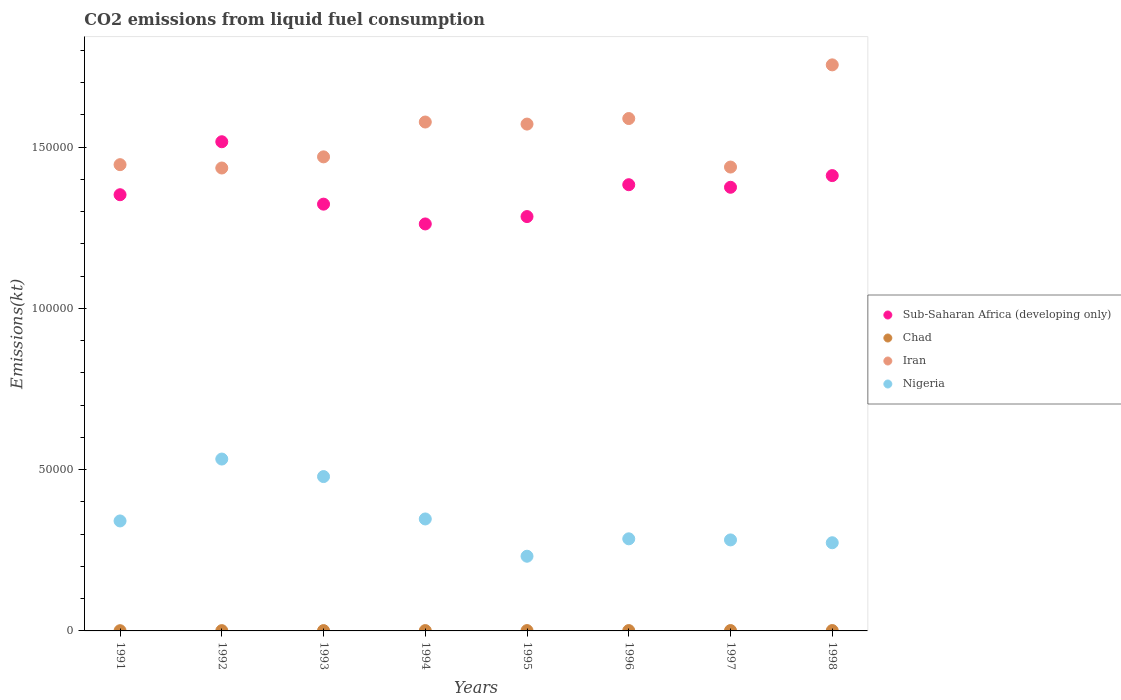Is the number of dotlines equal to the number of legend labels?
Ensure brevity in your answer.  Yes. What is the amount of CO2 emitted in Nigeria in 1992?
Ensure brevity in your answer.  5.33e+04. Across all years, what is the maximum amount of CO2 emitted in Iran?
Provide a succinct answer. 1.75e+05. Across all years, what is the minimum amount of CO2 emitted in Sub-Saharan Africa (developing only)?
Your answer should be very brief. 1.26e+05. What is the total amount of CO2 emitted in Sub-Saharan Africa (developing only) in the graph?
Give a very brief answer. 1.09e+06. What is the difference between the amount of CO2 emitted in Sub-Saharan Africa (developing only) in 1992 and that in 1994?
Provide a short and direct response. 2.55e+04. What is the difference between the amount of CO2 emitted in Chad in 1992 and the amount of CO2 emitted in Nigeria in 1995?
Keep it short and to the point. -2.31e+04. What is the average amount of CO2 emitted in Chad per year?
Provide a short and direct response. 99.47. In the year 1997, what is the difference between the amount of CO2 emitted in Nigeria and amount of CO2 emitted in Sub-Saharan Africa (developing only)?
Your answer should be very brief. -1.09e+05. What is the ratio of the amount of CO2 emitted in Sub-Saharan Africa (developing only) in 1994 to that in 1998?
Keep it short and to the point. 0.89. What is the difference between the highest and the second highest amount of CO2 emitted in Iran?
Provide a succinct answer. 1.66e+04. What is the difference between the highest and the lowest amount of CO2 emitted in Sub-Saharan Africa (developing only)?
Offer a terse response. 2.55e+04. In how many years, is the amount of CO2 emitted in Chad greater than the average amount of CO2 emitted in Chad taken over all years?
Give a very brief answer. 5. Is the sum of the amount of CO2 emitted in Chad in 1994 and 1997 greater than the maximum amount of CO2 emitted in Iran across all years?
Offer a terse response. No. Is it the case that in every year, the sum of the amount of CO2 emitted in Sub-Saharan Africa (developing only) and amount of CO2 emitted in Iran  is greater than the sum of amount of CO2 emitted in Chad and amount of CO2 emitted in Nigeria?
Your answer should be very brief. Yes. Does the amount of CO2 emitted in Iran monotonically increase over the years?
Give a very brief answer. No. Is the amount of CO2 emitted in Iran strictly greater than the amount of CO2 emitted in Nigeria over the years?
Your answer should be compact. Yes. How many dotlines are there?
Give a very brief answer. 4. How many years are there in the graph?
Give a very brief answer. 8. What is the difference between two consecutive major ticks on the Y-axis?
Your answer should be compact. 5.00e+04. Does the graph contain any zero values?
Keep it short and to the point. No. Does the graph contain grids?
Keep it short and to the point. No. Where does the legend appear in the graph?
Make the answer very short. Center right. What is the title of the graph?
Your answer should be compact. CO2 emissions from liquid fuel consumption. Does "European Union" appear as one of the legend labels in the graph?
Your answer should be very brief. No. What is the label or title of the X-axis?
Offer a terse response. Years. What is the label or title of the Y-axis?
Keep it short and to the point. Emissions(kt). What is the Emissions(kt) of Sub-Saharan Africa (developing only) in 1991?
Your response must be concise. 1.35e+05. What is the Emissions(kt) in Chad in 1991?
Keep it short and to the point. 69.67. What is the Emissions(kt) in Iran in 1991?
Provide a short and direct response. 1.45e+05. What is the Emissions(kt) of Nigeria in 1991?
Provide a succinct answer. 3.41e+04. What is the Emissions(kt) of Sub-Saharan Africa (developing only) in 1992?
Ensure brevity in your answer.  1.52e+05. What is the Emissions(kt) in Chad in 1992?
Make the answer very short. 88.01. What is the Emissions(kt) in Iran in 1992?
Provide a short and direct response. 1.44e+05. What is the Emissions(kt) of Nigeria in 1992?
Give a very brief answer. 5.33e+04. What is the Emissions(kt) of Sub-Saharan Africa (developing only) in 1993?
Your answer should be compact. 1.32e+05. What is the Emissions(kt) in Chad in 1993?
Offer a terse response. 99.01. What is the Emissions(kt) in Iran in 1993?
Offer a very short reply. 1.47e+05. What is the Emissions(kt) of Nigeria in 1993?
Provide a succinct answer. 4.79e+04. What is the Emissions(kt) of Sub-Saharan Africa (developing only) in 1994?
Provide a short and direct response. 1.26e+05. What is the Emissions(kt) in Chad in 1994?
Provide a short and direct response. 102.68. What is the Emissions(kt) in Iran in 1994?
Provide a short and direct response. 1.58e+05. What is the Emissions(kt) of Nigeria in 1994?
Offer a very short reply. 3.47e+04. What is the Emissions(kt) of Sub-Saharan Africa (developing only) in 1995?
Give a very brief answer. 1.28e+05. What is the Emissions(kt) in Chad in 1995?
Offer a terse response. 102.68. What is the Emissions(kt) in Iran in 1995?
Provide a succinct answer. 1.57e+05. What is the Emissions(kt) in Nigeria in 1995?
Ensure brevity in your answer.  2.32e+04. What is the Emissions(kt) in Sub-Saharan Africa (developing only) in 1996?
Give a very brief answer. 1.38e+05. What is the Emissions(kt) of Chad in 1996?
Offer a very short reply. 106.34. What is the Emissions(kt) in Iran in 1996?
Ensure brevity in your answer.  1.59e+05. What is the Emissions(kt) of Nigeria in 1996?
Give a very brief answer. 2.86e+04. What is the Emissions(kt) of Sub-Saharan Africa (developing only) in 1997?
Offer a terse response. 1.38e+05. What is the Emissions(kt) of Chad in 1997?
Offer a very short reply. 113.68. What is the Emissions(kt) in Iran in 1997?
Make the answer very short. 1.44e+05. What is the Emissions(kt) of Nigeria in 1997?
Your answer should be very brief. 2.82e+04. What is the Emissions(kt) in Sub-Saharan Africa (developing only) in 1998?
Offer a very short reply. 1.41e+05. What is the Emissions(kt) in Chad in 1998?
Your answer should be compact. 113.68. What is the Emissions(kt) in Iran in 1998?
Give a very brief answer. 1.75e+05. What is the Emissions(kt) in Nigeria in 1998?
Make the answer very short. 2.73e+04. Across all years, what is the maximum Emissions(kt) of Sub-Saharan Africa (developing only)?
Your answer should be compact. 1.52e+05. Across all years, what is the maximum Emissions(kt) of Chad?
Provide a succinct answer. 113.68. Across all years, what is the maximum Emissions(kt) of Iran?
Your answer should be very brief. 1.75e+05. Across all years, what is the maximum Emissions(kt) in Nigeria?
Keep it short and to the point. 5.33e+04. Across all years, what is the minimum Emissions(kt) in Sub-Saharan Africa (developing only)?
Offer a very short reply. 1.26e+05. Across all years, what is the minimum Emissions(kt) in Chad?
Ensure brevity in your answer.  69.67. Across all years, what is the minimum Emissions(kt) in Iran?
Your response must be concise. 1.44e+05. Across all years, what is the minimum Emissions(kt) of Nigeria?
Offer a terse response. 2.32e+04. What is the total Emissions(kt) in Sub-Saharan Africa (developing only) in the graph?
Your answer should be compact. 1.09e+06. What is the total Emissions(kt) in Chad in the graph?
Provide a short and direct response. 795.74. What is the total Emissions(kt) in Iran in the graph?
Offer a very short reply. 1.23e+06. What is the total Emissions(kt) in Nigeria in the graph?
Offer a terse response. 2.77e+05. What is the difference between the Emissions(kt) of Sub-Saharan Africa (developing only) in 1991 and that in 1992?
Give a very brief answer. -1.64e+04. What is the difference between the Emissions(kt) in Chad in 1991 and that in 1992?
Make the answer very short. -18.34. What is the difference between the Emissions(kt) in Iran in 1991 and that in 1992?
Your answer should be compact. 1037.76. What is the difference between the Emissions(kt) of Nigeria in 1991 and that in 1992?
Provide a short and direct response. -1.92e+04. What is the difference between the Emissions(kt) in Sub-Saharan Africa (developing only) in 1991 and that in 1993?
Keep it short and to the point. 2920.51. What is the difference between the Emissions(kt) in Chad in 1991 and that in 1993?
Provide a succinct answer. -29.34. What is the difference between the Emissions(kt) in Iran in 1991 and that in 1993?
Provide a succinct answer. -2416.55. What is the difference between the Emissions(kt) in Nigeria in 1991 and that in 1993?
Give a very brief answer. -1.38e+04. What is the difference between the Emissions(kt) in Sub-Saharan Africa (developing only) in 1991 and that in 1994?
Offer a terse response. 9058.79. What is the difference between the Emissions(kt) of Chad in 1991 and that in 1994?
Your answer should be compact. -33. What is the difference between the Emissions(kt) in Iran in 1991 and that in 1994?
Your answer should be very brief. -1.32e+04. What is the difference between the Emissions(kt) in Nigeria in 1991 and that in 1994?
Offer a very short reply. -616.06. What is the difference between the Emissions(kt) in Sub-Saharan Africa (developing only) in 1991 and that in 1995?
Ensure brevity in your answer.  6773.64. What is the difference between the Emissions(kt) in Chad in 1991 and that in 1995?
Offer a terse response. -33. What is the difference between the Emissions(kt) in Iran in 1991 and that in 1995?
Ensure brevity in your answer.  -1.26e+04. What is the difference between the Emissions(kt) of Nigeria in 1991 and that in 1995?
Offer a terse response. 1.09e+04. What is the difference between the Emissions(kt) in Sub-Saharan Africa (developing only) in 1991 and that in 1996?
Make the answer very short. -3105.17. What is the difference between the Emissions(kt) of Chad in 1991 and that in 1996?
Provide a succinct answer. -36.67. What is the difference between the Emissions(kt) of Iran in 1991 and that in 1996?
Keep it short and to the point. -1.43e+04. What is the difference between the Emissions(kt) in Nigeria in 1991 and that in 1996?
Your response must be concise. 5540.84. What is the difference between the Emissions(kt) in Sub-Saharan Africa (developing only) in 1991 and that in 1997?
Your response must be concise. -2311.31. What is the difference between the Emissions(kt) in Chad in 1991 and that in 1997?
Ensure brevity in your answer.  -44. What is the difference between the Emissions(kt) in Iran in 1991 and that in 1997?
Give a very brief answer. 744.4. What is the difference between the Emissions(kt) in Nigeria in 1991 and that in 1997?
Keep it short and to the point. 5881.87. What is the difference between the Emissions(kt) in Sub-Saharan Africa (developing only) in 1991 and that in 1998?
Keep it short and to the point. -5929.79. What is the difference between the Emissions(kt) of Chad in 1991 and that in 1998?
Your response must be concise. -44. What is the difference between the Emissions(kt) of Iran in 1991 and that in 1998?
Your response must be concise. -3.09e+04. What is the difference between the Emissions(kt) in Nigeria in 1991 and that in 1998?
Give a very brief answer. 6758.28. What is the difference between the Emissions(kt) in Sub-Saharan Africa (developing only) in 1992 and that in 1993?
Ensure brevity in your answer.  1.93e+04. What is the difference between the Emissions(kt) in Chad in 1992 and that in 1993?
Your answer should be compact. -11. What is the difference between the Emissions(kt) of Iran in 1992 and that in 1993?
Keep it short and to the point. -3454.31. What is the difference between the Emissions(kt) of Nigeria in 1992 and that in 1993?
Provide a succinct answer. 5434.49. What is the difference between the Emissions(kt) of Sub-Saharan Africa (developing only) in 1992 and that in 1994?
Give a very brief answer. 2.55e+04. What is the difference between the Emissions(kt) in Chad in 1992 and that in 1994?
Keep it short and to the point. -14.67. What is the difference between the Emissions(kt) of Iran in 1992 and that in 1994?
Offer a terse response. -1.43e+04. What is the difference between the Emissions(kt) of Nigeria in 1992 and that in 1994?
Provide a short and direct response. 1.86e+04. What is the difference between the Emissions(kt) of Sub-Saharan Africa (developing only) in 1992 and that in 1995?
Your answer should be compact. 2.32e+04. What is the difference between the Emissions(kt) of Chad in 1992 and that in 1995?
Make the answer very short. -14.67. What is the difference between the Emissions(kt) of Iran in 1992 and that in 1995?
Keep it short and to the point. -1.36e+04. What is the difference between the Emissions(kt) in Nigeria in 1992 and that in 1995?
Keep it short and to the point. 3.01e+04. What is the difference between the Emissions(kt) in Sub-Saharan Africa (developing only) in 1992 and that in 1996?
Your response must be concise. 1.33e+04. What is the difference between the Emissions(kt) in Chad in 1992 and that in 1996?
Ensure brevity in your answer.  -18.34. What is the difference between the Emissions(kt) in Iran in 1992 and that in 1996?
Give a very brief answer. -1.53e+04. What is the difference between the Emissions(kt) of Nigeria in 1992 and that in 1996?
Keep it short and to the point. 2.47e+04. What is the difference between the Emissions(kt) in Sub-Saharan Africa (developing only) in 1992 and that in 1997?
Your response must be concise. 1.41e+04. What is the difference between the Emissions(kt) in Chad in 1992 and that in 1997?
Offer a terse response. -25.67. What is the difference between the Emissions(kt) of Iran in 1992 and that in 1997?
Your answer should be very brief. -293.36. What is the difference between the Emissions(kt) in Nigeria in 1992 and that in 1997?
Your response must be concise. 2.51e+04. What is the difference between the Emissions(kt) of Sub-Saharan Africa (developing only) in 1992 and that in 1998?
Offer a terse response. 1.05e+04. What is the difference between the Emissions(kt) of Chad in 1992 and that in 1998?
Make the answer very short. -25.67. What is the difference between the Emissions(kt) of Iran in 1992 and that in 1998?
Offer a terse response. -3.20e+04. What is the difference between the Emissions(kt) of Nigeria in 1992 and that in 1998?
Keep it short and to the point. 2.59e+04. What is the difference between the Emissions(kt) in Sub-Saharan Africa (developing only) in 1993 and that in 1994?
Provide a succinct answer. 6138.28. What is the difference between the Emissions(kt) in Chad in 1993 and that in 1994?
Keep it short and to the point. -3.67. What is the difference between the Emissions(kt) in Iran in 1993 and that in 1994?
Your answer should be very brief. -1.08e+04. What is the difference between the Emissions(kt) in Nigeria in 1993 and that in 1994?
Offer a terse response. 1.31e+04. What is the difference between the Emissions(kt) of Sub-Saharan Africa (developing only) in 1993 and that in 1995?
Your answer should be compact. 3853.13. What is the difference between the Emissions(kt) of Chad in 1993 and that in 1995?
Give a very brief answer. -3.67. What is the difference between the Emissions(kt) of Iran in 1993 and that in 1995?
Give a very brief answer. -1.02e+04. What is the difference between the Emissions(kt) of Nigeria in 1993 and that in 1995?
Your answer should be very brief. 2.47e+04. What is the difference between the Emissions(kt) in Sub-Saharan Africa (developing only) in 1993 and that in 1996?
Your answer should be compact. -6025.69. What is the difference between the Emissions(kt) of Chad in 1993 and that in 1996?
Ensure brevity in your answer.  -7.33. What is the difference between the Emissions(kt) of Iran in 1993 and that in 1996?
Offer a terse response. -1.19e+04. What is the difference between the Emissions(kt) in Nigeria in 1993 and that in 1996?
Your answer should be compact. 1.93e+04. What is the difference between the Emissions(kt) in Sub-Saharan Africa (developing only) in 1993 and that in 1997?
Provide a succinct answer. -5231.82. What is the difference between the Emissions(kt) in Chad in 1993 and that in 1997?
Your answer should be very brief. -14.67. What is the difference between the Emissions(kt) in Iran in 1993 and that in 1997?
Offer a very short reply. 3160.95. What is the difference between the Emissions(kt) in Nigeria in 1993 and that in 1997?
Provide a succinct answer. 1.96e+04. What is the difference between the Emissions(kt) in Sub-Saharan Africa (developing only) in 1993 and that in 1998?
Provide a short and direct response. -8850.3. What is the difference between the Emissions(kt) of Chad in 1993 and that in 1998?
Your answer should be very brief. -14.67. What is the difference between the Emissions(kt) of Iran in 1993 and that in 1998?
Keep it short and to the point. -2.85e+04. What is the difference between the Emissions(kt) of Nigeria in 1993 and that in 1998?
Give a very brief answer. 2.05e+04. What is the difference between the Emissions(kt) in Sub-Saharan Africa (developing only) in 1994 and that in 1995?
Keep it short and to the point. -2285.15. What is the difference between the Emissions(kt) of Iran in 1994 and that in 1995?
Offer a very short reply. 641.73. What is the difference between the Emissions(kt) in Nigeria in 1994 and that in 1995?
Provide a short and direct response. 1.16e+04. What is the difference between the Emissions(kt) in Sub-Saharan Africa (developing only) in 1994 and that in 1996?
Give a very brief answer. -1.22e+04. What is the difference between the Emissions(kt) in Chad in 1994 and that in 1996?
Offer a very short reply. -3.67. What is the difference between the Emissions(kt) of Iran in 1994 and that in 1996?
Ensure brevity in your answer.  -1078.1. What is the difference between the Emissions(kt) of Nigeria in 1994 and that in 1996?
Offer a very short reply. 6156.89. What is the difference between the Emissions(kt) of Sub-Saharan Africa (developing only) in 1994 and that in 1997?
Make the answer very short. -1.14e+04. What is the difference between the Emissions(kt) in Chad in 1994 and that in 1997?
Offer a very short reply. -11. What is the difference between the Emissions(kt) of Iran in 1994 and that in 1997?
Make the answer very short. 1.40e+04. What is the difference between the Emissions(kt) in Nigeria in 1994 and that in 1997?
Your answer should be compact. 6497.92. What is the difference between the Emissions(kt) in Sub-Saharan Africa (developing only) in 1994 and that in 1998?
Your answer should be compact. -1.50e+04. What is the difference between the Emissions(kt) in Chad in 1994 and that in 1998?
Offer a terse response. -11. What is the difference between the Emissions(kt) of Iran in 1994 and that in 1998?
Offer a very short reply. -1.77e+04. What is the difference between the Emissions(kt) of Nigeria in 1994 and that in 1998?
Ensure brevity in your answer.  7374.34. What is the difference between the Emissions(kt) of Sub-Saharan Africa (developing only) in 1995 and that in 1996?
Ensure brevity in your answer.  -9878.82. What is the difference between the Emissions(kt) of Chad in 1995 and that in 1996?
Offer a terse response. -3.67. What is the difference between the Emissions(kt) in Iran in 1995 and that in 1996?
Offer a very short reply. -1719.82. What is the difference between the Emissions(kt) of Nigeria in 1995 and that in 1996?
Provide a short and direct response. -5397.82. What is the difference between the Emissions(kt) of Sub-Saharan Africa (developing only) in 1995 and that in 1997?
Give a very brief answer. -9084.95. What is the difference between the Emissions(kt) in Chad in 1995 and that in 1997?
Provide a succinct answer. -11. What is the difference between the Emissions(kt) of Iran in 1995 and that in 1997?
Offer a very short reply. 1.33e+04. What is the difference between the Emissions(kt) of Nigeria in 1995 and that in 1997?
Your answer should be very brief. -5056.79. What is the difference between the Emissions(kt) in Sub-Saharan Africa (developing only) in 1995 and that in 1998?
Offer a very short reply. -1.27e+04. What is the difference between the Emissions(kt) in Chad in 1995 and that in 1998?
Provide a short and direct response. -11. What is the difference between the Emissions(kt) of Iran in 1995 and that in 1998?
Make the answer very short. -1.84e+04. What is the difference between the Emissions(kt) in Nigeria in 1995 and that in 1998?
Keep it short and to the point. -4180.38. What is the difference between the Emissions(kt) in Sub-Saharan Africa (developing only) in 1996 and that in 1997?
Offer a very short reply. 793.87. What is the difference between the Emissions(kt) in Chad in 1996 and that in 1997?
Give a very brief answer. -7.33. What is the difference between the Emissions(kt) in Iran in 1996 and that in 1997?
Your response must be concise. 1.50e+04. What is the difference between the Emissions(kt) in Nigeria in 1996 and that in 1997?
Provide a short and direct response. 341.03. What is the difference between the Emissions(kt) of Sub-Saharan Africa (developing only) in 1996 and that in 1998?
Your answer should be very brief. -2824.62. What is the difference between the Emissions(kt) in Chad in 1996 and that in 1998?
Your answer should be very brief. -7.33. What is the difference between the Emissions(kt) in Iran in 1996 and that in 1998?
Provide a succinct answer. -1.66e+04. What is the difference between the Emissions(kt) in Nigeria in 1996 and that in 1998?
Your response must be concise. 1217.44. What is the difference between the Emissions(kt) in Sub-Saharan Africa (developing only) in 1997 and that in 1998?
Keep it short and to the point. -3618.48. What is the difference between the Emissions(kt) in Iran in 1997 and that in 1998?
Keep it short and to the point. -3.17e+04. What is the difference between the Emissions(kt) of Nigeria in 1997 and that in 1998?
Provide a short and direct response. 876.41. What is the difference between the Emissions(kt) in Sub-Saharan Africa (developing only) in 1991 and the Emissions(kt) in Chad in 1992?
Your response must be concise. 1.35e+05. What is the difference between the Emissions(kt) of Sub-Saharan Africa (developing only) in 1991 and the Emissions(kt) of Iran in 1992?
Provide a short and direct response. -8283.72. What is the difference between the Emissions(kt) of Sub-Saharan Africa (developing only) in 1991 and the Emissions(kt) of Nigeria in 1992?
Ensure brevity in your answer.  8.19e+04. What is the difference between the Emissions(kt) of Chad in 1991 and the Emissions(kt) of Iran in 1992?
Ensure brevity in your answer.  -1.43e+05. What is the difference between the Emissions(kt) of Chad in 1991 and the Emissions(kt) of Nigeria in 1992?
Ensure brevity in your answer.  -5.32e+04. What is the difference between the Emissions(kt) in Iran in 1991 and the Emissions(kt) in Nigeria in 1992?
Offer a very short reply. 9.13e+04. What is the difference between the Emissions(kt) in Sub-Saharan Africa (developing only) in 1991 and the Emissions(kt) in Chad in 1993?
Offer a very short reply. 1.35e+05. What is the difference between the Emissions(kt) of Sub-Saharan Africa (developing only) in 1991 and the Emissions(kt) of Iran in 1993?
Give a very brief answer. -1.17e+04. What is the difference between the Emissions(kt) of Sub-Saharan Africa (developing only) in 1991 and the Emissions(kt) of Nigeria in 1993?
Give a very brief answer. 8.74e+04. What is the difference between the Emissions(kt) in Chad in 1991 and the Emissions(kt) in Iran in 1993?
Offer a very short reply. -1.47e+05. What is the difference between the Emissions(kt) in Chad in 1991 and the Emissions(kt) in Nigeria in 1993?
Offer a terse response. -4.78e+04. What is the difference between the Emissions(kt) of Iran in 1991 and the Emissions(kt) of Nigeria in 1993?
Your answer should be very brief. 9.67e+04. What is the difference between the Emissions(kt) of Sub-Saharan Africa (developing only) in 1991 and the Emissions(kt) of Chad in 1994?
Give a very brief answer. 1.35e+05. What is the difference between the Emissions(kt) of Sub-Saharan Africa (developing only) in 1991 and the Emissions(kt) of Iran in 1994?
Your answer should be compact. -2.25e+04. What is the difference between the Emissions(kt) of Sub-Saharan Africa (developing only) in 1991 and the Emissions(kt) of Nigeria in 1994?
Make the answer very short. 1.01e+05. What is the difference between the Emissions(kt) of Chad in 1991 and the Emissions(kt) of Iran in 1994?
Offer a very short reply. -1.58e+05. What is the difference between the Emissions(kt) of Chad in 1991 and the Emissions(kt) of Nigeria in 1994?
Keep it short and to the point. -3.46e+04. What is the difference between the Emissions(kt) of Iran in 1991 and the Emissions(kt) of Nigeria in 1994?
Offer a terse response. 1.10e+05. What is the difference between the Emissions(kt) of Sub-Saharan Africa (developing only) in 1991 and the Emissions(kt) of Chad in 1995?
Your response must be concise. 1.35e+05. What is the difference between the Emissions(kt) in Sub-Saharan Africa (developing only) in 1991 and the Emissions(kt) in Iran in 1995?
Offer a very short reply. -2.19e+04. What is the difference between the Emissions(kt) in Sub-Saharan Africa (developing only) in 1991 and the Emissions(kt) in Nigeria in 1995?
Make the answer very short. 1.12e+05. What is the difference between the Emissions(kt) in Chad in 1991 and the Emissions(kt) in Iran in 1995?
Your answer should be very brief. -1.57e+05. What is the difference between the Emissions(kt) in Chad in 1991 and the Emissions(kt) in Nigeria in 1995?
Your answer should be compact. -2.31e+04. What is the difference between the Emissions(kt) of Iran in 1991 and the Emissions(kt) of Nigeria in 1995?
Keep it short and to the point. 1.21e+05. What is the difference between the Emissions(kt) of Sub-Saharan Africa (developing only) in 1991 and the Emissions(kt) of Chad in 1996?
Your response must be concise. 1.35e+05. What is the difference between the Emissions(kt) of Sub-Saharan Africa (developing only) in 1991 and the Emissions(kt) of Iran in 1996?
Make the answer very short. -2.36e+04. What is the difference between the Emissions(kt) of Sub-Saharan Africa (developing only) in 1991 and the Emissions(kt) of Nigeria in 1996?
Your answer should be very brief. 1.07e+05. What is the difference between the Emissions(kt) of Chad in 1991 and the Emissions(kt) of Iran in 1996?
Your answer should be very brief. -1.59e+05. What is the difference between the Emissions(kt) in Chad in 1991 and the Emissions(kt) in Nigeria in 1996?
Ensure brevity in your answer.  -2.85e+04. What is the difference between the Emissions(kt) in Iran in 1991 and the Emissions(kt) in Nigeria in 1996?
Give a very brief answer. 1.16e+05. What is the difference between the Emissions(kt) of Sub-Saharan Africa (developing only) in 1991 and the Emissions(kt) of Chad in 1997?
Your answer should be very brief. 1.35e+05. What is the difference between the Emissions(kt) in Sub-Saharan Africa (developing only) in 1991 and the Emissions(kt) in Iran in 1997?
Keep it short and to the point. -8577.08. What is the difference between the Emissions(kt) of Sub-Saharan Africa (developing only) in 1991 and the Emissions(kt) of Nigeria in 1997?
Your answer should be very brief. 1.07e+05. What is the difference between the Emissions(kt) of Chad in 1991 and the Emissions(kt) of Iran in 1997?
Provide a short and direct response. -1.44e+05. What is the difference between the Emissions(kt) in Chad in 1991 and the Emissions(kt) in Nigeria in 1997?
Keep it short and to the point. -2.81e+04. What is the difference between the Emissions(kt) in Iran in 1991 and the Emissions(kt) in Nigeria in 1997?
Ensure brevity in your answer.  1.16e+05. What is the difference between the Emissions(kt) in Sub-Saharan Africa (developing only) in 1991 and the Emissions(kt) in Chad in 1998?
Ensure brevity in your answer.  1.35e+05. What is the difference between the Emissions(kt) of Sub-Saharan Africa (developing only) in 1991 and the Emissions(kt) of Iran in 1998?
Offer a very short reply. -4.03e+04. What is the difference between the Emissions(kt) in Sub-Saharan Africa (developing only) in 1991 and the Emissions(kt) in Nigeria in 1998?
Provide a short and direct response. 1.08e+05. What is the difference between the Emissions(kt) in Chad in 1991 and the Emissions(kt) in Iran in 1998?
Give a very brief answer. -1.75e+05. What is the difference between the Emissions(kt) of Chad in 1991 and the Emissions(kt) of Nigeria in 1998?
Offer a very short reply. -2.73e+04. What is the difference between the Emissions(kt) in Iran in 1991 and the Emissions(kt) in Nigeria in 1998?
Provide a short and direct response. 1.17e+05. What is the difference between the Emissions(kt) of Sub-Saharan Africa (developing only) in 1992 and the Emissions(kt) of Chad in 1993?
Make the answer very short. 1.52e+05. What is the difference between the Emissions(kt) of Sub-Saharan Africa (developing only) in 1992 and the Emissions(kt) of Iran in 1993?
Offer a terse response. 4688.93. What is the difference between the Emissions(kt) of Sub-Saharan Africa (developing only) in 1992 and the Emissions(kt) of Nigeria in 1993?
Provide a succinct answer. 1.04e+05. What is the difference between the Emissions(kt) of Chad in 1992 and the Emissions(kt) of Iran in 1993?
Your response must be concise. -1.47e+05. What is the difference between the Emissions(kt) in Chad in 1992 and the Emissions(kt) in Nigeria in 1993?
Your answer should be very brief. -4.78e+04. What is the difference between the Emissions(kt) of Iran in 1992 and the Emissions(kt) of Nigeria in 1993?
Provide a succinct answer. 9.57e+04. What is the difference between the Emissions(kt) in Sub-Saharan Africa (developing only) in 1992 and the Emissions(kt) in Chad in 1994?
Your response must be concise. 1.52e+05. What is the difference between the Emissions(kt) in Sub-Saharan Africa (developing only) in 1992 and the Emissions(kt) in Iran in 1994?
Provide a succinct answer. -6114.05. What is the difference between the Emissions(kt) of Sub-Saharan Africa (developing only) in 1992 and the Emissions(kt) of Nigeria in 1994?
Provide a succinct answer. 1.17e+05. What is the difference between the Emissions(kt) in Chad in 1992 and the Emissions(kt) in Iran in 1994?
Keep it short and to the point. -1.58e+05. What is the difference between the Emissions(kt) of Chad in 1992 and the Emissions(kt) of Nigeria in 1994?
Provide a short and direct response. -3.46e+04. What is the difference between the Emissions(kt) of Iran in 1992 and the Emissions(kt) of Nigeria in 1994?
Give a very brief answer. 1.09e+05. What is the difference between the Emissions(kt) of Sub-Saharan Africa (developing only) in 1992 and the Emissions(kt) of Chad in 1995?
Offer a terse response. 1.52e+05. What is the difference between the Emissions(kt) in Sub-Saharan Africa (developing only) in 1992 and the Emissions(kt) in Iran in 1995?
Your response must be concise. -5472.33. What is the difference between the Emissions(kt) of Sub-Saharan Africa (developing only) in 1992 and the Emissions(kt) of Nigeria in 1995?
Offer a terse response. 1.29e+05. What is the difference between the Emissions(kt) of Chad in 1992 and the Emissions(kt) of Iran in 1995?
Offer a terse response. -1.57e+05. What is the difference between the Emissions(kt) in Chad in 1992 and the Emissions(kt) in Nigeria in 1995?
Make the answer very short. -2.31e+04. What is the difference between the Emissions(kt) of Iran in 1992 and the Emissions(kt) of Nigeria in 1995?
Your answer should be compact. 1.20e+05. What is the difference between the Emissions(kt) in Sub-Saharan Africa (developing only) in 1992 and the Emissions(kt) in Chad in 1996?
Offer a terse response. 1.52e+05. What is the difference between the Emissions(kt) of Sub-Saharan Africa (developing only) in 1992 and the Emissions(kt) of Iran in 1996?
Offer a terse response. -7192.15. What is the difference between the Emissions(kt) in Sub-Saharan Africa (developing only) in 1992 and the Emissions(kt) in Nigeria in 1996?
Your response must be concise. 1.23e+05. What is the difference between the Emissions(kt) in Chad in 1992 and the Emissions(kt) in Iran in 1996?
Give a very brief answer. -1.59e+05. What is the difference between the Emissions(kt) in Chad in 1992 and the Emissions(kt) in Nigeria in 1996?
Your answer should be compact. -2.85e+04. What is the difference between the Emissions(kt) in Iran in 1992 and the Emissions(kt) in Nigeria in 1996?
Ensure brevity in your answer.  1.15e+05. What is the difference between the Emissions(kt) in Sub-Saharan Africa (developing only) in 1992 and the Emissions(kt) in Chad in 1997?
Your answer should be very brief. 1.52e+05. What is the difference between the Emissions(kt) in Sub-Saharan Africa (developing only) in 1992 and the Emissions(kt) in Iran in 1997?
Your answer should be compact. 7849.88. What is the difference between the Emissions(kt) in Sub-Saharan Africa (developing only) in 1992 and the Emissions(kt) in Nigeria in 1997?
Ensure brevity in your answer.  1.23e+05. What is the difference between the Emissions(kt) of Chad in 1992 and the Emissions(kt) of Iran in 1997?
Give a very brief answer. -1.44e+05. What is the difference between the Emissions(kt) in Chad in 1992 and the Emissions(kt) in Nigeria in 1997?
Provide a succinct answer. -2.81e+04. What is the difference between the Emissions(kt) of Iran in 1992 and the Emissions(kt) of Nigeria in 1997?
Make the answer very short. 1.15e+05. What is the difference between the Emissions(kt) in Sub-Saharan Africa (developing only) in 1992 and the Emissions(kt) in Chad in 1998?
Give a very brief answer. 1.52e+05. What is the difference between the Emissions(kt) of Sub-Saharan Africa (developing only) in 1992 and the Emissions(kt) of Iran in 1998?
Give a very brief answer. -2.38e+04. What is the difference between the Emissions(kt) in Sub-Saharan Africa (developing only) in 1992 and the Emissions(kt) in Nigeria in 1998?
Provide a succinct answer. 1.24e+05. What is the difference between the Emissions(kt) in Chad in 1992 and the Emissions(kt) in Iran in 1998?
Provide a succinct answer. -1.75e+05. What is the difference between the Emissions(kt) in Chad in 1992 and the Emissions(kt) in Nigeria in 1998?
Your answer should be very brief. -2.72e+04. What is the difference between the Emissions(kt) of Iran in 1992 and the Emissions(kt) of Nigeria in 1998?
Give a very brief answer. 1.16e+05. What is the difference between the Emissions(kt) of Sub-Saharan Africa (developing only) in 1993 and the Emissions(kt) of Chad in 1994?
Your response must be concise. 1.32e+05. What is the difference between the Emissions(kt) in Sub-Saharan Africa (developing only) in 1993 and the Emissions(kt) in Iran in 1994?
Keep it short and to the point. -2.55e+04. What is the difference between the Emissions(kt) in Sub-Saharan Africa (developing only) in 1993 and the Emissions(kt) in Nigeria in 1994?
Your response must be concise. 9.76e+04. What is the difference between the Emissions(kt) in Chad in 1993 and the Emissions(kt) in Iran in 1994?
Keep it short and to the point. -1.58e+05. What is the difference between the Emissions(kt) of Chad in 1993 and the Emissions(kt) of Nigeria in 1994?
Give a very brief answer. -3.46e+04. What is the difference between the Emissions(kt) in Iran in 1993 and the Emissions(kt) in Nigeria in 1994?
Make the answer very short. 1.12e+05. What is the difference between the Emissions(kt) of Sub-Saharan Africa (developing only) in 1993 and the Emissions(kt) of Chad in 1995?
Give a very brief answer. 1.32e+05. What is the difference between the Emissions(kt) of Sub-Saharan Africa (developing only) in 1993 and the Emissions(kt) of Iran in 1995?
Your answer should be compact. -2.48e+04. What is the difference between the Emissions(kt) in Sub-Saharan Africa (developing only) in 1993 and the Emissions(kt) in Nigeria in 1995?
Give a very brief answer. 1.09e+05. What is the difference between the Emissions(kt) in Chad in 1993 and the Emissions(kt) in Iran in 1995?
Keep it short and to the point. -1.57e+05. What is the difference between the Emissions(kt) in Chad in 1993 and the Emissions(kt) in Nigeria in 1995?
Make the answer very short. -2.31e+04. What is the difference between the Emissions(kt) of Iran in 1993 and the Emissions(kt) of Nigeria in 1995?
Your answer should be compact. 1.24e+05. What is the difference between the Emissions(kt) of Sub-Saharan Africa (developing only) in 1993 and the Emissions(kt) of Chad in 1996?
Make the answer very short. 1.32e+05. What is the difference between the Emissions(kt) of Sub-Saharan Africa (developing only) in 1993 and the Emissions(kt) of Iran in 1996?
Keep it short and to the point. -2.65e+04. What is the difference between the Emissions(kt) of Sub-Saharan Africa (developing only) in 1993 and the Emissions(kt) of Nigeria in 1996?
Offer a terse response. 1.04e+05. What is the difference between the Emissions(kt) of Chad in 1993 and the Emissions(kt) of Iran in 1996?
Your answer should be very brief. -1.59e+05. What is the difference between the Emissions(kt) of Chad in 1993 and the Emissions(kt) of Nigeria in 1996?
Provide a short and direct response. -2.85e+04. What is the difference between the Emissions(kt) in Iran in 1993 and the Emissions(kt) in Nigeria in 1996?
Keep it short and to the point. 1.18e+05. What is the difference between the Emissions(kt) in Sub-Saharan Africa (developing only) in 1993 and the Emissions(kt) in Chad in 1997?
Provide a short and direct response. 1.32e+05. What is the difference between the Emissions(kt) of Sub-Saharan Africa (developing only) in 1993 and the Emissions(kt) of Iran in 1997?
Offer a very short reply. -1.15e+04. What is the difference between the Emissions(kt) in Sub-Saharan Africa (developing only) in 1993 and the Emissions(kt) in Nigeria in 1997?
Offer a terse response. 1.04e+05. What is the difference between the Emissions(kt) of Chad in 1993 and the Emissions(kt) of Iran in 1997?
Your response must be concise. -1.44e+05. What is the difference between the Emissions(kt) in Chad in 1993 and the Emissions(kt) in Nigeria in 1997?
Your answer should be compact. -2.81e+04. What is the difference between the Emissions(kt) in Iran in 1993 and the Emissions(kt) in Nigeria in 1997?
Provide a short and direct response. 1.19e+05. What is the difference between the Emissions(kt) of Sub-Saharan Africa (developing only) in 1993 and the Emissions(kt) of Chad in 1998?
Offer a terse response. 1.32e+05. What is the difference between the Emissions(kt) of Sub-Saharan Africa (developing only) in 1993 and the Emissions(kt) of Iran in 1998?
Make the answer very short. -4.32e+04. What is the difference between the Emissions(kt) in Sub-Saharan Africa (developing only) in 1993 and the Emissions(kt) in Nigeria in 1998?
Make the answer very short. 1.05e+05. What is the difference between the Emissions(kt) of Chad in 1993 and the Emissions(kt) of Iran in 1998?
Give a very brief answer. -1.75e+05. What is the difference between the Emissions(kt) in Chad in 1993 and the Emissions(kt) in Nigeria in 1998?
Your answer should be very brief. -2.72e+04. What is the difference between the Emissions(kt) of Iran in 1993 and the Emissions(kt) of Nigeria in 1998?
Your answer should be very brief. 1.20e+05. What is the difference between the Emissions(kt) in Sub-Saharan Africa (developing only) in 1994 and the Emissions(kt) in Chad in 1995?
Give a very brief answer. 1.26e+05. What is the difference between the Emissions(kt) in Sub-Saharan Africa (developing only) in 1994 and the Emissions(kt) in Iran in 1995?
Ensure brevity in your answer.  -3.10e+04. What is the difference between the Emissions(kt) of Sub-Saharan Africa (developing only) in 1994 and the Emissions(kt) of Nigeria in 1995?
Give a very brief answer. 1.03e+05. What is the difference between the Emissions(kt) of Chad in 1994 and the Emissions(kt) of Iran in 1995?
Keep it short and to the point. -1.57e+05. What is the difference between the Emissions(kt) in Chad in 1994 and the Emissions(kt) in Nigeria in 1995?
Provide a succinct answer. -2.31e+04. What is the difference between the Emissions(kt) of Iran in 1994 and the Emissions(kt) of Nigeria in 1995?
Your answer should be compact. 1.35e+05. What is the difference between the Emissions(kt) of Sub-Saharan Africa (developing only) in 1994 and the Emissions(kt) of Chad in 1996?
Your response must be concise. 1.26e+05. What is the difference between the Emissions(kt) in Sub-Saharan Africa (developing only) in 1994 and the Emissions(kt) in Iran in 1996?
Make the answer very short. -3.27e+04. What is the difference between the Emissions(kt) in Sub-Saharan Africa (developing only) in 1994 and the Emissions(kt) in Nigeria in 1996?
Your response must be concise. 9.76e+04. What is the difference between the Emissions(kt) of Chad in 1994 and the Emissions(kt) of Iran in 1996?
Your answer should be compact. -1.59e+05. What is the difference between the Emissions(kt) in Chad in 1994 and the Emissions(kt) in Nigeria in 1996?
Your response must be concise. -2.85e+04. What is the difference between the Emissions(kt) in Iran in 1994 and the Emissions(kt) in Nigeria in 1996?
Your response must be concise. 1.29e+05. What is the difference between the Emissions(kt) in Sub-Saharan Africa (developing only) in 1994 and the Emissions(kt) in Chad in 1997?
Give a very brief answer. 1.26e+05. What is the difference between the Emissions(kt) in Sub-Saharan Africa (developing only) in 1994 and the Emissions(kt) in Iran in 1997?
Offer a very short reply. -1.76e+04. What is the difference between the Emissions(kt) in Sub-Saharan Africa (developing only) in 1994 and the Emissions(kt) in Nigeria in 1997?
Make the answer very short. 9.80e+04. What is the difference between the Emissions(kt) of Chad in 1994 and the Emissions(kt) of Iran in 1997?
Provide a short and direct response. -1.44e+05. What is the difference between the Emissions(kt) of Chad in 1994 and the Emissions(kt) of Nigeria in 1997?
Your response must be concise. -2.81e+04. What is the difference between the Emissions(kt) of Iran in 1994 and the Emissions(kt) of Nigeria in 1997?
Offer a very short reply. 1.30e+05. What is the difference between the Emissions(kt) of Sub-Saharan Africa (developing only) in 1994 and the Emissions(kt) of Chad in 1998?
Your answer should be very brief. 1.26e+05. What is the difference between the Emissions(kt) in Sub-Saharan Africa (developing only) in 1994 and the Emissions(kt) in Iran in 1998?
Provide a succinct answer. -4.93e+04. What is the difference between the Emissions(kt) of Sub-Saharan Africa (developing only) in 1994 and the Emissions(kt) of Nigeria in 1998?
Provide a succinct answer. 9.88e+04. What is the difference between the Emissions(kt) of Chad in 1994 and the Emissions(kt) of Iran in 1998?
Your answer should be compact. -1.75e+05. What is the difference between the Emissions(kt) of Chad in 1994 and the Emissions(kt) of Nigeria in 1998?
Provide a short and direct response. -2.72e+04. What is the difference between the Emissions(kt) of Iran in 1994 and the Emissions(kt) of Nigeria in 1998?
Provide a succinct answer. 1.30e+05. What is the difference between the Emissions(kt) of Sub-Saharan Africa (developing only) in 1995 and the Emissions(kt) of Chad in 1996?
Make the answer very short. 1.28e+05. What is the difference between the Emissions(kt) in Sub-Saharan Africa (developing only) in 1995 and the Emissions(kt) in Iran in 1996?
Provide a succinct answer. -3.04e+04. What is the difference between the Emissions(kt) in Sub-Saharan Africa (developing only) in 1995 and the Emissions(kt) in Nigeria in 1996?
Provide a succinct answer. 9.99e+04. What is the difference between the Emissions(kt) in Chad in 1995 and the Emissions(kt) in Iran in 1996?
Provide a succinct answer. -1.59e+05. What is the difference between the Emissions(kt) in Chad in 1995 and the Emissions(kt) in Nigeria in 1996?
Your response must be concise. -2.85e+04. What is the difference between the Emissions(kt) in Iran in 1995 and the Emissions(kt) in Nigeria in 1996?
Your answer should be very brief. 1.29e+05. What is the difference between the Emissions(kt) in Sub-Saharan Africa (developing only) in 1995 and the Emissions(kt) in Chad in 1997?
Make the answer very short. 1.28e+05. What is the difference between the Emissions(kt) in Sub-Saharan Africa (developing only) in 1995 and the Emissions(kt) in Iran in 1997?
Offer a very short reply. -1.54e+04. What is the difference between the Emissions(kt) in Sub-Saharan Africa (developing only) in 1995 and the Emissions(kt) in Nigeria in 1997?
Make the answer very short. 1.00e+05. What is the difference between the Emissions(kt) in Chad in 1995 and the Emissions(kt) in Iran in 1997?
Offer a terse response. -1.44e+05. What is the difference between the Emissions(kt) in Chad in 1995 and the Emissions(kt) in Nigeria in 1997?
Keep it short and to the point. -2.81e+04. What is the difference between the Emissions(kt) of Iran in 1995 and the Emissions(kt) of Nigeria in 1997?
Your answer should be compact. 1.29e+05. What is the difference between the Emissions(kt) of Sub-Saharan Africa (developing only) in 1995 and the Emissions(kt) of Chad in 1998?
Provide a short and direct response. 1.28e+05. What is the difference between the Emissions(kt) of Sub-Saharan Africa (developing only) in 1995 and the Emissions(kt) of Iran in 1998?
Keep it short and to the point. -4.70e+04. What is the difference between the Emissions(kt) of Sub-Saharan Africa (developing only) in 1995 and the Emissions(kt) of Nigeria in 1998?
Provide a succinct answer. 1.01e+05. What is the difference between the Emissions(kt) in Chad in 1995 and the Emissions(kt) in Iran in 1998?
Offer a terse response. -1.75e+05. What is the difference between the Emissions(kt) in Chad in 1995 and the Emissions(kt) in Nigeria in 1998?
Give a very brief answer. -2.72e+04. What is the difference between the Emissions(kt) in Iran in 1995 and the Emissions(kt) in Nigeria in 1998?
Your answer should be compact. 1.30e+05. What is the difference between the Emissions(kt) of Sub-Saharan Africa (developing only) in 1996 and the Emissions(kt) of Chad in 1997?
Provide a succinct answer. 1.38e+05. What is the difference between the Emissions(kt) of Sub-Saharan Africa (developing only) in 1996 and the Emissions(kt) of Iran in 1997?
Offer a very short reply. -5471.9. What is the difference between the Emissions(kt) in Sub-Saharan Africa (developing only) in 1996 and the Emissions(kt) in Nigeria in 1997?
Your answer should be compact. 1.10e+05. What is the difference between the Emissions(kt) of Chad in 1996 and the Emissions(kt) of Iran in 1997?
Your answer should be compact. -1.44e+05. What is the difference between the Emissions(kt) in Chad in 1996 and the Emissions(kt) in Nigeria in 1997?
Provide a short and direct response. -2.81e+04. What is the difference between the Emissions(kt) in Iran in 1996 and the Emissions(kt) in Nigeria in 1997?
Give a very brief answer. 1.31e+05. What is the difference between the Emissions(kt) in Sub-Saharan Africa (developing only) in 1996 and the Emissions(kt) in Chad in 1998?
Offer a terse response. 1.38e+05. What is the difference between the Emissions(kt) of Sub-Saharan Africa (developing only) in 1996 and the Emissions(kt) of Iran in 1998?
Give a very brief answer. -3.72e+04. What is the difference between the Emissions(kt) of Sub-Saharan Africa (developing only) in 1996 and the Emissions(kt) of Nigeria in 1998?
Make the answer very short. 1.11e+05. What is the difference between the Emissions(kt) of Chad in 1996 and the Emissions(kt) of Iran in 1998?
Offer a very short reply. -1.75e+05. What is the difference between the Emissions(kt) of Chad in 1996 and the Emissions(kt) of Nigeria in 1998?
Provide a succinct answer. -2.72e+04. What is the difference between the Emissions(kt) in Iran in 1996 and the Emissions(kt) in Nigeria in 1998?
Provide a short and direct response. 1.32e+05. What is the difference between the Emissions(kt) of Sub-Saharan Africa (developing only) in 1997 and the Emissions(kt) of Chad in 1998?
Offer a very short reply. 1.37e+05. What is the difference between the Emissions(kt) in Sub-Saharan Africa (developing only) in 1997 and the Emissions(kt) in Iran in 1998?
Provide a succinct answer. -3.79e+04. What is the difference between the Emissions(kt) in Sub-Saharan Africa (developing only) in 1997 and the Emissions(kt) in Nigeria in 1998?
Make the answer very short. 1.10e+05. What is the difference between the Emissions(kt) in Chad in 1997 and the Emissions(kt) in Iran in 1998?
Provide a succinct answer. -1.75e+05. What is the difference between the Emissions(kt) in Chad in 1997 and the Emissions(kt) in Nigeria in 1998?
Make the answer very short. -2.72e+04. What is the difference between the Emissions(kt) in Iran in 1997 and the Emissions(kt) in Nigeria in 1998?
Offer a very short reply. 1.16e+05. What is the average Emissions(kt) in Sub-Saharan Africa (developing only) per year?
Your response must be concise. 1.36e+05. What is the average Emissions(kt) of Chad per year?
Provide a succinct answer. 99.47. What is the average Emissions(kt) of Iran per year?
Offer a terse response. 1.54e+05. What is the average Emissions(kt) of Nigeria per year?
Offer a terse response. 3.47e+04. In the year 1991, what is the difference between the Emissions(kt) in Sub-Saharan Africa (developing only) and Emissions(kt) in Chad?
Make the answer very short. 1.35e+05. In the year 1991, what is the difference between the Emissions(kt) of Sub-Saharan Africa (developing only) and Emissions(kt) of Iran?
Give a very brief answer. -9321.48. In the year 1991, what is the difference between the Emissions(kt) of Sub-Saharan Africa (developing only) and Emissions(kt) of Nigeria?
Keep it short and to the point. 1.01e+05. In the year 1991, what is the difference between the Emissions(kt) in Chad and Emissions(kt) in Iran?
Provide a succinct answer. -1.44e+05. In the year 1991, what is the difference between the Emissions(kt) in Chad and Emissions(kt) in Nigeria?
Your answer should be very brief. -3.40e+04. In the year 1991, what is the difference between the Emissions(kt) of Iran and Emissions(kt) of Nigeria?
Provide a short and direct response. 1.10e+05. In the year 1992, what is the difference between the Emissions(kt) of Sub-Saharan Africa (developing only) and Emissions(kt) of Chad?
Keep it short and to the point. 1.52e+05. In the year 1992, what is the difference between the Emissions(kt) of Sub-Saharan Africa (developing only) and Emissions(kt) of Iran?
Offer a terse response. 8143.24. In the year 1992, what is the difference between the Emissions(kt) in Sub-Saharan Africa (developing only) and Emissions(kt) in Nigeria?
Provide a short and direct response. 9.84e+04. In the year 1992, what is the difference between the Emissions(kt) in Chad and Emissions(kt) in Iran?
Provide a succinct answer. -1.43e+05. In the year 1992, what is the difference between the Emissions(kt) of Chad and Emissions(kt) of Nigeria?
Keep it short and to the point. -5.32e+04. In the year 1992, what is the difference between the Emissions(kt) of Iran and Emissions(kt) of Nigeria?
Keep it short and to the point. 9.02e+04. In the year 1993, what is the difference between the Emissions(kt) of Sub-Saharan Africa (developing only) and Emissions(kt) of Chad?
Your answer should be very brief. 1.32e+05. In the year 1993, what is the difference between the Emissions(kt) of Sub-Saharan Africa (developing only) and Emissions(kt) of Iran?
Keep it short and to the point. -1.47e+04. In the year 1993, what is the difference between the Emissions(kt) of Sub-Saharan Africa (developing only) and Emissions(kt) of Nigeria?
Your answer should be compact. 8.45e+04. In the year 1993, what is the difference between the Emissions(kt) of Chad and Emissions(kt) of Iran?
Ensure brevity in your answer.  -1.47e+05. In the year 1993, what is the difference between the Emissions(kt) in Chad and Emissions(kt) in Nigeria?
Offer a very short reply. -4.78e+04. In the year 1993, what is the difference between the Emissions(kt) of Iran and Emissions(kt) of Nigeria?
Ensure brevity in your answer.  9.91e+04. In the year 1994, what is the difference between the Emissions(kt) of Sub-Saharan Africa (developing only) and Emissions(kt) of Chad?
Keep it short and to the point. 1.26e+05. In the year 1994, what is the difference between the Emissions(kt) of Sub-Saharan Africa (developing only) and Emissions(kt) of Iran?
Offer a terse response. -3.16e+04. In the year 1994, what is the difference between the Emissions(kt) of Sub-Saharan Africa (developing only) and Emissions(kt) of Nigeria?
Provide a short and direct response. 9.15e+04. In the year 1994, what is the difference between the Emissions(kt) of Chad and Emissions(kt) of Iran?
Make the answer very short. -1.58e+05. In the year 1994, what is the difference between the Emissions(kt) of Chad and Emissions(kt) of Nigeria?
Your answer should be very brief. -3.46e+04. In the year 1994, what is the difference between the Emissions(kt) of Iran and Emissions(kt) of Nigeria?
Your response must be concise. 1.23e+05. In the year 1995, what is the difference between the Emissions(kt) in Sub-Saharan Africa (developing only) and Emissions(kt) in Chad?
Your answer should be very brief. 1.28e+05. In the year 1995, what is the difference between the Emissions(kt) of Sub-Saharan Africa (developing only) and Emissions(kt) of Iran?
Offer a terse response. -2.87e+04. In the year 1995, what is the difference between the Emissions(kt) of Sub-Saharan Africa (developing only) and Emissions(kt) of Nigeria?
Your answer should be compact. 1.05e+05. In the year 1995, what is the difference between the Emissions(kt) in Chad and Emissions(kt) in Iran?
Provide a short and direct response. -1.57e+05. In the year 1995, what is the difference between the Emissions(kt) of Chad and Emissions(kt) of Nigeria?
Make the answer very short. -2.31e+04. In the year 1995, what is the difference between the Emissions(kt) of Iran and Emissions(kt) of Nigeria?
Your response must be concise. 1.34e+05. In the year 1996, what is the difference between the Emissions(kt) in Sub-Saharan Africa (developing only) and Emissions(kt) in Chad?
Give a very brief answer. 1.38e+05. In the year 1996, what is the difference between the Emissions(kt) of Sub-Saharan Africa (developing only) and Emissions(kt) of Iran?
Offer a terse response. -2.05e+04. In the year 1996, what is the difference between the Emissions(kt) in Sub-Saharan Africa (developing only) and Emissions(kt) in Nigeria?
Your response must be concise. 1.10e+05. In the year 1996, what is the difference between the Emissions(kt) in Chad and Emissions(kt) in Iran?
Your answer should be very brief. -1.59e+05. In the year 1996, what is the difference between the Emissions(kt) in Chad and Emissions(kt) in Nigeria?
Make the answer very short. -2.84e+04. In the year 1996, what is the difference between the Emissions(kt) of Iran and Emissions(kt) of Nigeria?
Keep it short and to the point. 1.30e+05. In the year 1997, what is the difference between the Emissions(kt) in Sub-Saharan Africa (developing only) and Emissions(kt) in Chad?
Make the answer very short. 1.37e+05. In the year 1997, what is the difference between the Emissions(kt) of Sub-Saharan Africa (developing only) and Emissions(kt) of Iran?
Your response must be concise. -6265.77. In the year 1997, what is the difference between the Emissions(kt) in Sub-Saharan Africa (developing only) and Emissions(kt) in Nigeria?
Your answer should be compact. 1.09e+05. In the year 1997, what is the difference between the Emissions(kt) of Chad and Emissions(kt) of Iran?
Ensure brevity in your answer.  -1.44e+05. In the year 1997, what is the difference between the Emissions(kt) of Chad and Emissions(kt) of Nigeria?
Provide a short and direct response. -2.81e+04. In the year 1997, what is the difference between the Emissions(kt) of Iran and Emissions(kt) of Nigeria?
Provide a succinct answer. 1.16e+05. In the year 1998, what is the difference between the Emissions(kt) in Sub-Saharan Africa (developing only) and Emissions(kt) in Chad?
Offer a very short reply. 1.41e+05. In the year 1998, what is the difference between the Emissions(kt) of Sub-Saharan Africa (developing only) and Emissions(kt) of Iran?
Offer a terse response. -3.43e+04. In the year 1998, what is the difference between the Emissions(kt) in Sub-Saharan Africa (developing only) and Emissions(kt) in Nigeria?
Offer a terse response. 1.14e+05. In the year 1998, what is the difference between the Emissions(kt) in Chad and Emissions(kt) in Iran?
Offer a very short reply. -1.75e+05. In the year 1998, what is the difference between the Emissions(kt) of Chad and Emissions(kt) of Nigeria?
Keep it short and to the point. -2.72e+04. In the year 1998, what is the difference between the Emissions(kt) in Iran and Emissions(kt) in Nigeria?
Your response must be concise. 1.48e+05. What is the ratio of the Emissions(kt) in Sub-Saharan Africa (developing only) in 1991 to that in 1992?
Your response must be concise. 0.89. What is the ratio of the Emissions(kt) in Chad in 1991 to that in 1992?
Your response must be concise. 0.79. What is the ratio of the Emissions(kt) in Nigeria in 1991 to that in 1992?
Give a very brief answer. 0.64. What is the ratio of the Emissions(kt) of Sub-Saharan Africa (developing only) in 1991 to that in 1993?
Keep it short and to the point. 1.02. What is the ratio of the Emissions(kt) in Chad in 1991 to that in 1993?
Keep it short and to the point. 0.7. What is the ratio of the Emissions(kt) of Iran in 1991 to that in 1993?
Ensure brevity in your answer.  0.98. What is the ratio of the Emissions(kt) in Nigeria in 1991 to that in 1993?
Keep it short and to the point. 0.71. What is the ratio of the Emissions(kt) of Sub-Saharan Africa (developing only) in 1991 to that in 1994?
Offer a very short reply. 1.07. What is the ratio of the Emissions(kt) in Chad in 1991 to that in 1994?
Offer a very short reply. 0.68. What is the ratio of the Emissions(kt) of Iran in 1991 to that in 1994?
Give a very brief answer. 0.92. What is the ratio of the Emissions(kt) in Nigeria in 1991 to that in 1994?
Your answer should be very brief. 0.98. What is the ratio of the Emissions(kt) in Sub-Saharan Africa (developing only) in 1991 to that in 1995?
Your answer should be very brief. 1.05. What is the ratio of the Emissions(kt) of Chad in 1991 to that in 1995?
Provide a short and direct response. 0.68. What is the ratio of the Emissions(kt) of Nigeria in 1991 to that in 1995?
Your answer should be very brief. 1.47. What is the ratio of the Emissions(kt) of Sub-Saharan Africa (developing only) in 1991 to that in 1996?
Your answer should be compact. 0.98. What is the ratio of the Emissions(kt) of Chad in 1991 to that in 1996?
Give a very brief answer. 0.66. What is the ratio of the Emissions(kt) in Iran in 1991 to that in 1996?
Keep it short and to the point. 0.91. What is the ratio of the Emissions(kt) in Nigeria in 1991 to that in 1996?
Offer a terse response. 1.19. What is the ratio of the Emissions(kt) of Sub-Saharan Africa (developing only) in 1991 to that in 1997?
Make the answer very short. 0.98. What is the ratio of the Emissions(kt) in Chad in 1991 to that in 1997?
Provide a succinct answer. 0.61. What is the ratio of the Emissions(kt) of Nigeria in 1991 to that in 1997?
Keep it short and to the point. 1.21. What is the ratio of the Emissions(kt) of Sub-Saharan Africa (developing only) in 1991 to that in 1998?
Offer a terse response. 0.96. What is the ratio of the Emissions(kt) in Chad in 1991 to that in 1998?
Give a very brief answer. 0.61. What is the ratio of the Emissions(kt) in Iran in 1991 to that in 1998?
Keep it short and to the point. 0.82. What is the ratio of the Emissions(kt) in Nigeria in 1991 to that in 1998?
Ensure brevity in your answer.  1.25. What is the ratio of the Emissions(kt) of Sub-Saharan Africa (developing only) in 1992 to that in 1993?
Offer a terse response. 1.15. What is the ratio of the Emissions(kt) in Iran in 1992 to that in 1993?
Provide a succinct answer. 0.98. What is the ratio of the Emissions(kt) of Nigeria in 1992 to that in 1993?
Offer a terse response. 1.11. What is the ratio of the Emissions(kt) in Sub-Saharan Africa (developing only) in 1992 to that in 1994?
Your response must be concise. 1.2. What is the ratio of the Emissions(kt) in Chad in 1992 to that in 1994?
Your answer should be compact. 0.86. What is the ratio of the Emissions(kt) in Iran in 1992 to that in 1994?
Your response must be concise. 0.91. What is the ratio of the Emissions(kt) in Nigeria in 1992 to that in 1994?
Offer a very short reply. 1.54. What is the ratio of the Emissions(kt) of Sub-Saharan Africa (developing only) in 1992 to that in 1995?
Make the answer very short. 1.18. What is the ratio of the Emissions(kt) of Iran in 1992 to that in 1995?
Your response must be concise. 0.91. What is the ratio of the Emissions(kt) in Nigeria in 1992 to that in 1995?
Provide a succinct answer. 2.3. What is the ratio of the Emissions(kt) of Sub-Saharan Africa (developing only) in 1992 to that in 1996?
Offer a terse response. 1.1. What is the ratio of the Emissions(kt) in Chad in 1992 to that in 1996?
Offer a very short reply. 0.83. What is the ratio of the Emissions(kt) in Iran in 1992 to that in 1996?
Your answer should be compact. 0.9. What is the ratio of the Emissions(kt) of Nigeria in 1992 to that in 1996?
Provide a short and direct response. 1.87. What is the ratio of the Emissions(kt) of Sub-Saharan Africa (developing only) in 1992 to that in 1997?
Your response must be concise. 1.1. What is the ratio of the Emissions(kt) in Chad in 1992 to that in 1997?
Make the answer very short. 0.77. What is the ratio of the Emissions(kt) of Nigeria in 1992 to that in 1997?
Your response must be concise. 1.89. What is the ratio of the Emissions(kt) of Sub-Saharan Africa (developing only) in 1992 to that in 1998?
Your response must be concise. 1.07. What is the ratio of the Emissions(kt) in Chad in 1992 to that in 1998?
Offer a terse response. 0.77. What is the ratio of the Emissions(kt) of Iran in 1992 to that in 1998?
Give a very brief answer. 0.82. What is the ratio of the Emissions(kt) in Nigeria in 1992 to that in 1998?
Your answer should be compact. 1.95. What is the ratio of the Emissions(kt) in Sub-Saharan Africa (developing only) in 1993 to that in 1994?
Ensure brevity in your answer.  1.05. What is the ratio of the Emissions(kt) of Chad in 1993 to that in 1994?
Keep it short and to the point. 0.96. What is the ratio of the Emissions(kt) in Iran in 1993 to that in 1994?
Your answer should be compact. 0.93. What is the ratio of the Emissions(kt) of Nigeria in 1993 to that in 1994?
Give a very brief answer. 1.38. What is the ratio of the Emissions(kt) of Sub-Saharan Africa (developing only) in 1993 to that in 1995?
Provide a short and direct response. 1.03. What is the ratio of the Emissions(kt) of Chad in 1993 to that in 1995?
Make the answer very short. 0.96. What is the ratio of the Emissions(kt) of Iran in 1993 to that in 1995?
Offer a terse response. 0.94. What is the ratio of the Emissions(kt) of Nigeria in 1993 to that in 1995?
Keep it short and to the point. 2.07. What is the ratio of the Emissions(kt) of Sub-Saharan Africa (developing only) in 1993 to that in 1996?
Offer a very short reply. 0.96. What is the ratio of the Emissions(kt) in Iran in 1993 to that in 1996?
Provide a succinct answer. 0.93. What is the ratio of the Emissions(kt) of Nigeria in 1993 to that in 1996?
Ensure brevity in your answer.  1.68. What is the ratio of the Emissions(kt) of Chad in 1993 to that in 1997?
Your answer should be very brief. 0.87. What is the ratio of the Emissions(kt) of Iran in 1993 to that in 1997?
Your answer should be very brief. 1.02. What is the ratio of the Emissions(kt) of Nigeria in 1993 to that in 1997?
Provide a succinct answer. 1.7. What is the ratio of the Emissions(kt) of Sub-Saharan Africa (developing only) in 1993 to that in 1998?
Your answer should be very brief. 0.94. What is the ratio of the Emissions(kt) in Chad in 1993 to that in 1998?
Make the answer very short. 0.87. What is the ratio of the Emissions(kt) in Iran in 1993 to that in 1998?
Provide a succinct answer. 0.84. What is the ratio of the Emissions(kt) in Nigeria in 1993 to that in 1998?
Offer a terse response. 1.75. What is the ratio of the Emissions(kt) of Sub-Saharan Africa (developing only) in 1994 to that in 1995?
Provide a short and direct response. 0.98. What is the ratio of the Emissions(kt) in Iran in 1994 to that in 1995?
Ensure brevity in your answer.  1. What is the ratio of the Emissions(kt) in Nigeria in 1994 to that in 1995?
Your answer should be very brief. 1.5. What is the ratio of the Emissions(kt) of Sub-Saharan Africa (developing only) in 1994 to that in 1996?
Offer a very short reply. 0.91. What is the ratio of the Emissions(kt) of Chad in 1994 to that in 1996?
Ensure brevity in your answer.  0.97. What is the ratio of the Emissions(kt) in Nigeria in 1994 to that in 1996?
Your answer should be very brief. 1.22. What is the ratio of the Emissions(kt) in Sub-Saharan Africa (developing only) in 1994 to that in 1997?
Offer a very short reply. 0.92. What is the ratio of the Emissions(kt) in Chad in 1994 to that in 1997?
Your answer should be compact. 0.9. What is the ratio of the Emissions(kt) in Iran in 1994 to that in 1997?
Give a very brief answer. 1.1. What is the ratio of the Emissions(kt) in Nigeria in 1994 to that in 1997?
Provide a short and direct response. 1.23. What is the ratio of the Emissions(kt) in Sub-Saharan Africa (developing only) in 1994 to that in 1998?
Your answer should be very brief. 0.89. What is the ratio of the Emissions(kt) in Chad in 1994 to that in 1998?
Make the answer very short. 0.9. What is the ratio of the Emissions(kt) of Iran in 1994 to that in 1998?
Your answer should be compact. 0.9. What is the ratio of the Emissions(kt) of Nigeria in 1994 to that in 1998?
Ensure brevity in your answer.  1.27. What is the ratio of the Emissions(kt) of Chad in 1995 to that in 1996?
Your answer should be very brief. 0.97. What is the ratio of the Emissions(kt) in Nigeria in 1995 to that in 1996?
Offer a very short reply. 0.81. What is the ratio of the Emissions(kt) of Sub-Saharan Africa (developing only) in 1995 to that in 1997?
Offer a very short reply. 0.93. What is the ratio of the Emissions(kt) in Chad in 1995 to that in 1997?
Provide a short and direct response. 0.9. What is the ratio of the Emissions(kt) of Iran in 1995 to that in 1997?
Your response must be concise. 1.09. What is the ratio of the Emissions(kt) of Nigeria in 1995 to that in 1997?
Your answer should be compact. 0.82. What is the ratio of the Emissions(kt) in Sub-Saharan Africa (developing only) in 1995 to that in 1998?
Keep it short and to the point. 0.91. What is the ratio of the Emissions(kt) of Chad in 1995 to that in 1998?
Keep it short and to the point. 0.9. What is the ratio of the Emissions(kt) of Iran in 1995 to that in 1998?
Your answer should be very brief. 0.9. What is the ratio of the Emissions(kt) in Nigeria in 1995 to that in 1998?
Your response must be concise. 0.85. What is the ratio of the Emissions(kt) of Sub-Saharan Africa (developing only) in 1996 to that in 1997?
Your answer should be compact. 1.01. What is the ratio of the Emissions(kt) of Chad in 1996 to that in 1997?
Offer a very short reply. 0.94. What is the ratio of the Emissions(kt) in Iran in 1996 to that in 1997?
Your response must be concise. 1.1. What is the ratio of the Emissions(kt) of Nigeria in 1996 to that in 1997?
Your answer should be compact. 1.01. What is the ratio of the Emissions(kt) in Chad in 1996 to that in 1998?
Your answer should be compact. 0.94. What is the ratio of the Emissions(kt) of Iran in 1996 to that in 1998?
Give a very brief answer. 0.91. What is the ratio of the Emissions(kt) of Nigeria in 1996 to that in 1998?
Your answer should be very brief. 1.04. What is the ratio of the Emissions(kt) of Sub-Saharan Africa (developing only) in 1997 to that in 1998?
Your response must be concise. 0.97. What is the ratio of the Emissions(kt) of Chad in 1997 to that in 1998?
Your answer should be compact. 1. What is the ratio of the Emissions(kt) of Iran in 1997 to that in 1998?
Your answer should be very brief. 0.82. What is the ratio of the Emissions(kt) of Nigeria in 1997 to that in 1998?
Give a very brief answer. 1.03. What is the difference between the highest and the second highest Emissions(kt) in Sub-Saharan Africa (developing only)?
Your answer should be very brief. 1.05e+04. What is the difference between the highest and the second highest Emissions(kt) of Iran?
Provide a short and direct response. 1.66e+04. What is the difference between the highest and the second highest Emissions(kt) of Nigeria?
Keep it short and to the point. 5434.49. What is the difference between the highest and the lowest Emissions(kt) of Sub-Saharan Africa (developing only)?
Ensure brevity in your answer.  2.55e+04. What is the difference between the highest and the lowest Emissions(kt) in Chad?
Provide a succinct answer. 44. What is the difference between the highest and the lowest Emissions(kt) in Iran?
Keep it short and to the point. 3.20e+04. What is the difference between the highest and the lowest Emissions(kt) of Nigeria?
Give a very brief answer. 3.01e+04. 